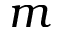Convert formula to latex. <formula><loc_0><loc_0><loc_500><loc_500>m</formula> 